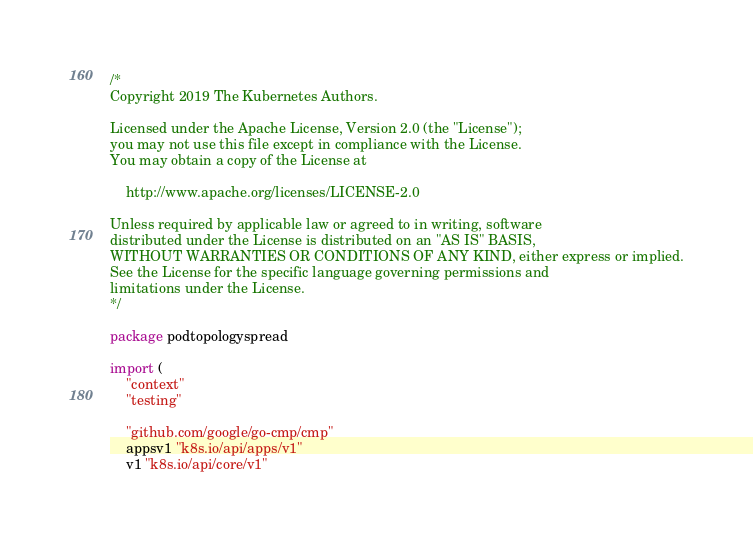Convert code to text. <code><loc_0><loc_0><loc_500><loc_500><_Go_>/*
Copyright 2019 The Kubernetes Authors.

Licensed under the Apache License, Version 2.0 (the "License");
you may not use this file except in compliance with the License.
You may obtain a copy of the License at

    http://www.apache.org/licenses/LICENSE-2.0

Unless required by applicable law or agreed to in writing, software
distributed under the License is distributed on an "AS IS" BASIS,
WITHOUT WARRANTIES OR CONDITIONS OF ANY KIND, either express or implied.
See the License for the specific language governing permissions and
limitations under the License.
*/

package podtopologyspread

import (
	"context"
	"testing"

	"github.com/google/go-cmp/cmp"
	appsv1 "k8s.io/api/apps/v1"
	v1 "k8s.io/api/core/v1"</code> 